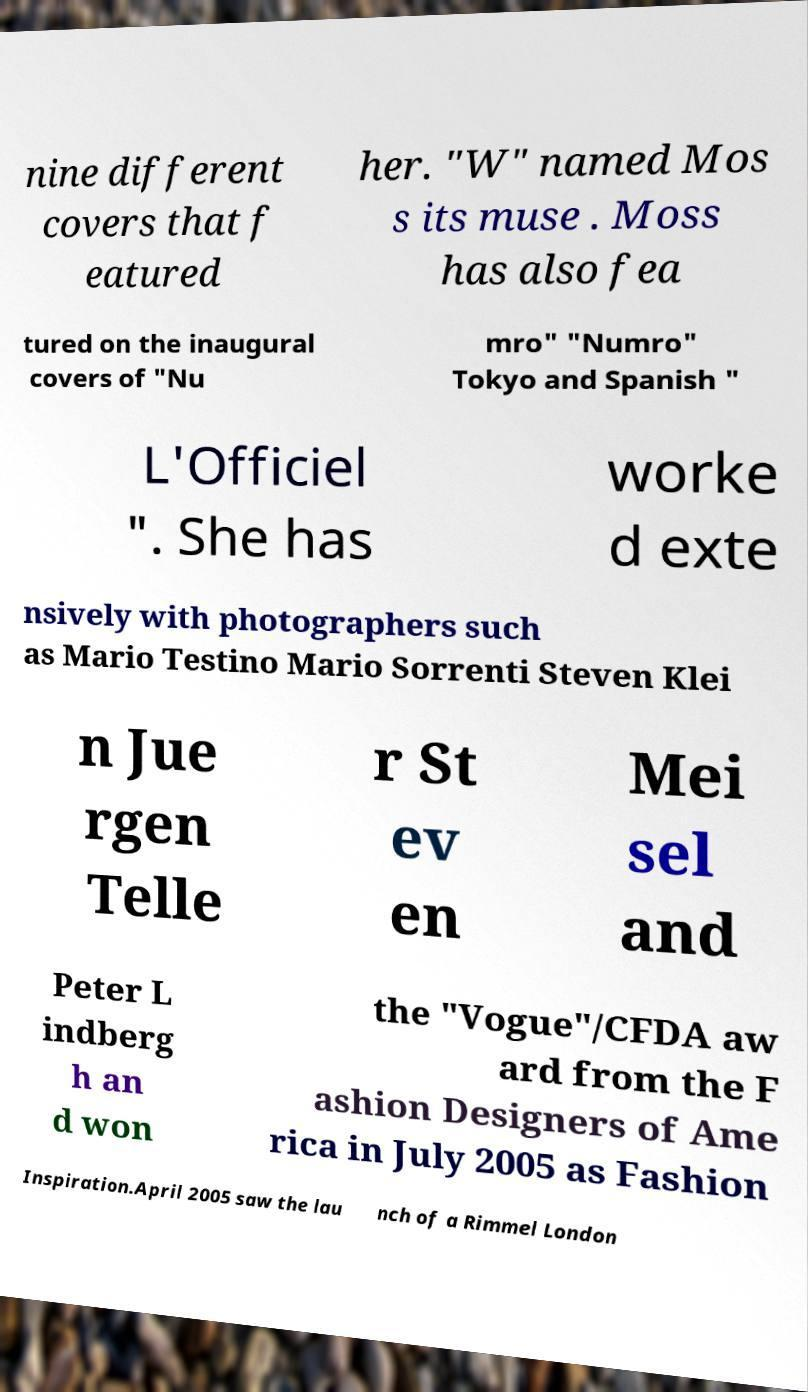Can you accurately transcribe the text from the provided image for me? nine different covers that f eatured her. "W" named Mos s its muse . Moss has also fea tured on the inaugural covers of "Nu mro" "Numro" Tokyo and Spanish " L'Officiel ". She has worke d exte nsively with photographers such as Mario Testino Mario Sorrenti Steven Klei n Jue rgen Telle r St ev en Mei sel and Peter L indberg h an d won the "Vogue"/CFDA aw ard from the F ashion Designers of Ame rica in July 2005 as Fashion Inspiration.April 2005 saw the lau nch of a Rimmel London 